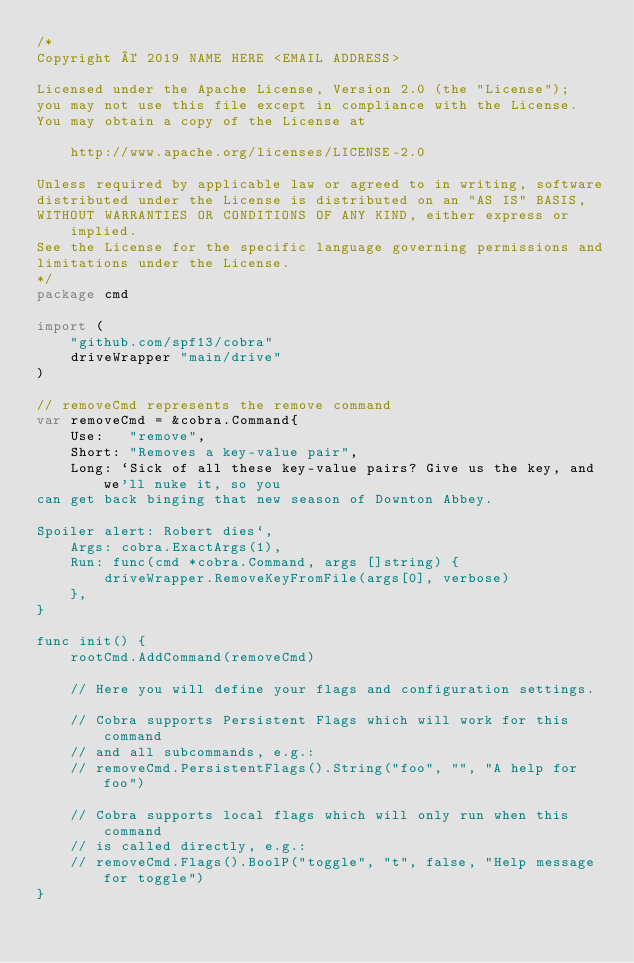Convert code to text. <code><loc_0><loc_0><loc_500><loc_500><_Go_>/*
Copyright © 2019 NAME HERE <EMAIL ADDRESS>

Licensed under the Apache License, Version 2.0 (the "License");
you may not use this file except in compliance with the License.
You may obtain a copy of the License at

    http://www.apache.org/licenses/LICENSE-2.0

Unless required by applicable law or agreed to in writing, software
distributed under the License is distributed on an "AS IS" BASIS,
WITHOUT WARRANTIES OR CONDITIONS OF ANY KIND, either express or implied.
See the License for the specific language governing permissions and
limitations under the License.
*/
package cmd

import (
	"github.com/spf13/cobra"
	driveWrapper "main/drive"
)

// removeCmd represents the remove command
var removeCmd = &cobra.Command{
	Use:   "remove",
	Short: "Removes a key-value pair",
	Long: `Sick of all these key-value pairs? Give us the key, and we'll nuke it, so you
can get back binging that new season of Downton Abbey.

Spoiler alert: Robert dies`,
	Args: cobra.ExactArgs(1),
	Run: func(cmd *cobra.Command, args []string) {
		driveWrapper.RemoveKeyFromFile(args[0], verbose)
	},
}

func init() {
	rootCmd.AddCommand(removeCmd)

	// Here you will define your flags and configuration settings.

	// Cobra supports Persistent Flags which will work for this command
	// and all subcommands, e.g.:
	// removeCmd.PersistentFlags().String("foo", "", "A help for foo")

	// Cobra supports local flags which will only run when this command
	// is called directly, e.g.:
	// removeCmd.Flags().BoolP("toggle", "t", false, "Help message for toggle")
}
</code> 